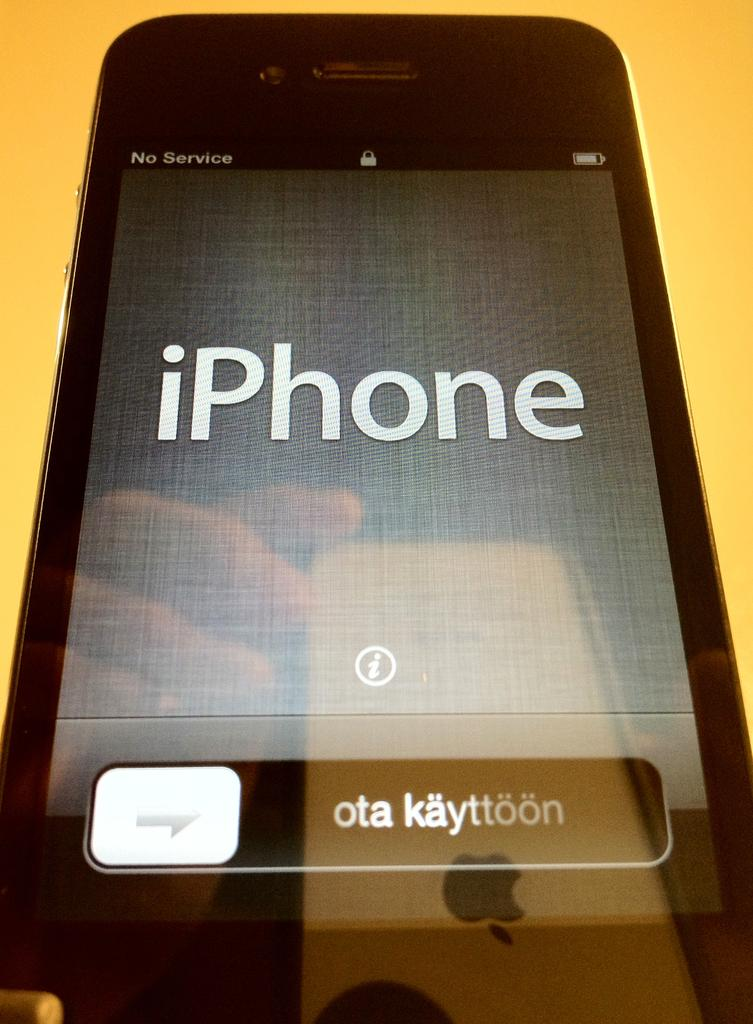<image>
Summarize the visual content of the image. A close-up of an iPhone display screen which reads "no service". 